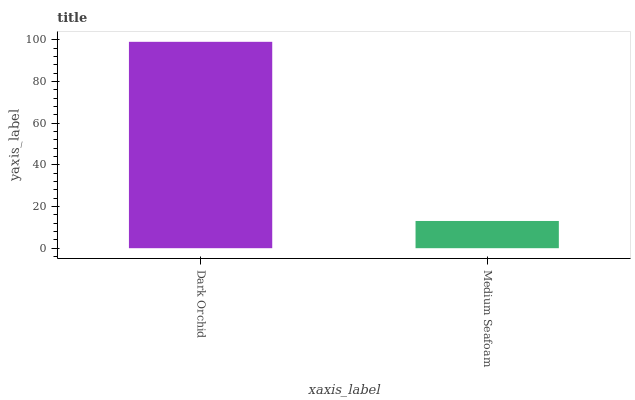Is Medium Seafoam the minimum?
Answer yes or no. Yes. Is Dark Orchid the maximum?
Answer yes or no. Yes. Is Medium Seafoam the maximum?
Answer yes or no. No. Is Dark Orchid greater than Medium Seafoam?
Answer yes or no. Yes. Is Medium Seafoam less than Dark Orchid?
Answer yes or no. Yes. Is Medium Seafoam greater than Dark Orchid?
Answer yes or no. No. Is Dark Orchid less than Medium Seafoam?
Answer yes or no. No. Is Dark Orchid the high median?
Answer yes or no. Yes. Is Medium Seafoam the low median?
Answer yes or no. Yes. Is Medium Seafoam the high median?
Answer yes or no. No. Is Dark Orchid the low median?
Answer yes or no. No. 